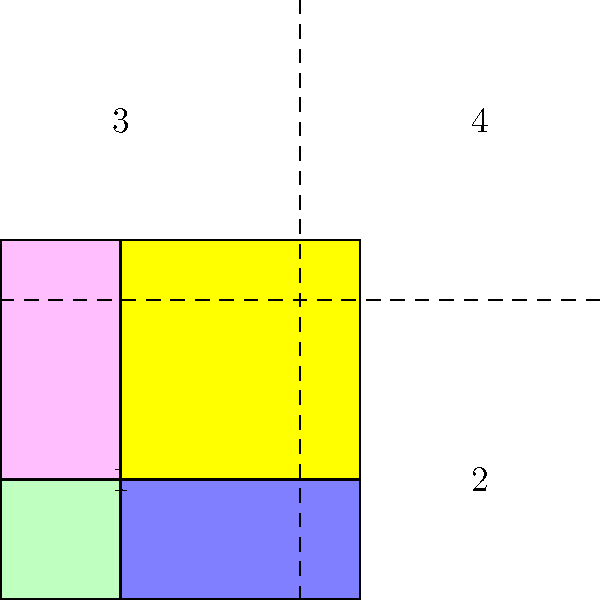As a history enthusiast, you've come across a fragmented historical map of ancient Rome. The map has been divided into four pieces, labeled 1 to 4. If you were to reconstruct the map correctly, which piece would be in the top-right corner? To solve this puzzle, we need to analyze the shape and orientation of each piece:

1. Piece 1 (green) has a convex corner in the bottom-left, suggesting it belongs in the bottom-left of the completed map.
2. Piece 2 (blue) has a convex corner in the top-left, indicating it should be in the bottom-right.
3. Piece 3 (pink) has a convex corner in the bottom-right, meaning it should be in the top-left.
4. Piece 4 (yellow) has a convex corner in the top-right, which places it in the top-right of the completed map.

The question specifically asks for the piece in the top-right corner. Based on our analysis, this would be piece 4 (yellow).

This type of spatial reasoning is crucial in historical map reconstruction, as it allows historians to piece together fragmented artifacts and gain a more complete understanding of ancient cartography.
Answer: 4 